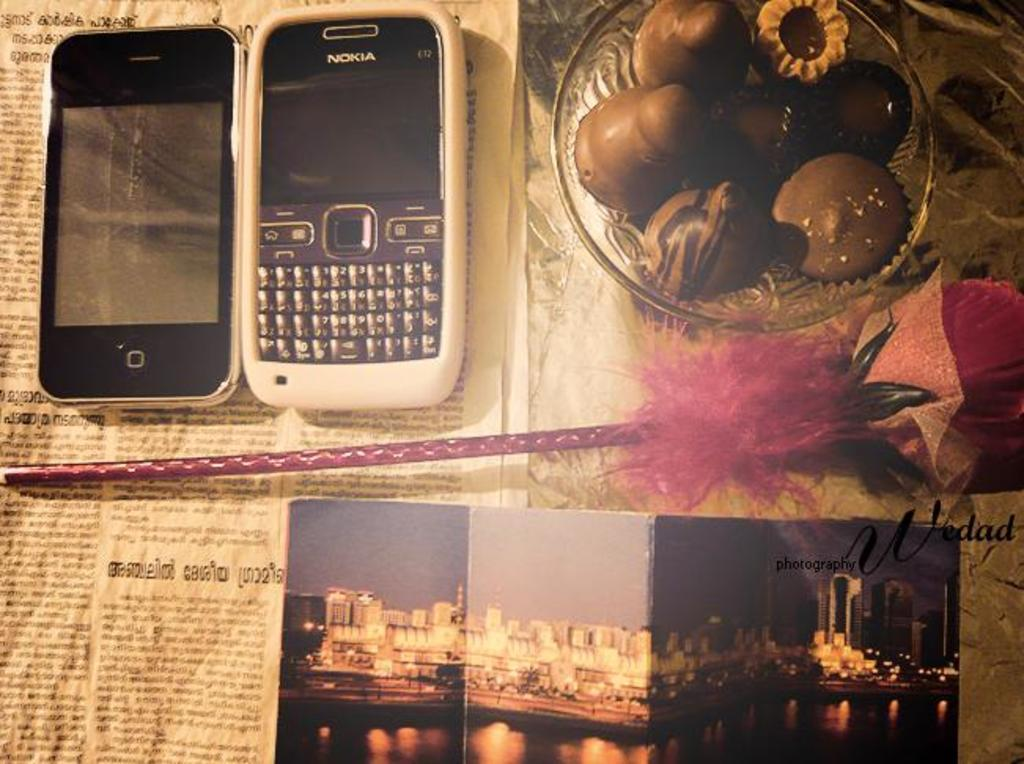Provide a one-sentence caption for the provided image. A Nokia cell phone sits on top of a newspaper next to a bowl of food. 